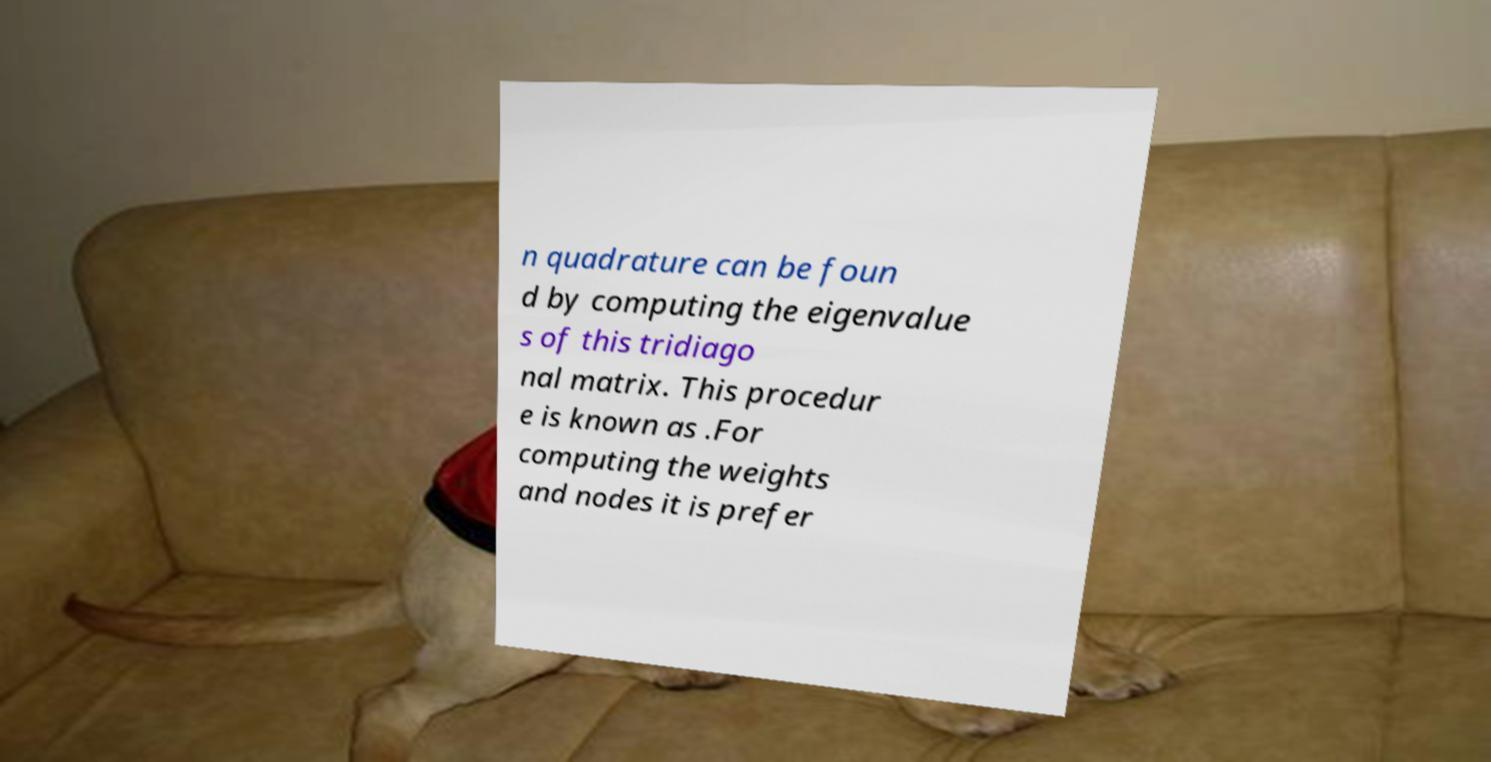What messages or text are displayed in this image? I need them in a readable, typed format. n quadrature can be foun d by computing the eigenvalue s of this tridiago nal matrix. This procedur e is known as .For computing the weights and nodes it is prefer 